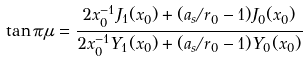Convert formula to latex. <formula><loc_0><loc_0><loc_500><loc_500>\tan \pi \mu = { \frac { 2 x _ { 0 } ^ { - 1 } J _ { 1 } ( x _ { 0 } ) + ( a _ { s } / r _ { 0 } - 1 ) J _ { 0 } ( x _ { 0 } ) } { 2 x _ { 0 } ^ { - 1 } Y _ { 1 } ( x _ { 0 } ) + ( a _ { s } / r _ { 0 } - 1 ) Y _ { 0 } ( x _ { 0 } ) } }</formula> 